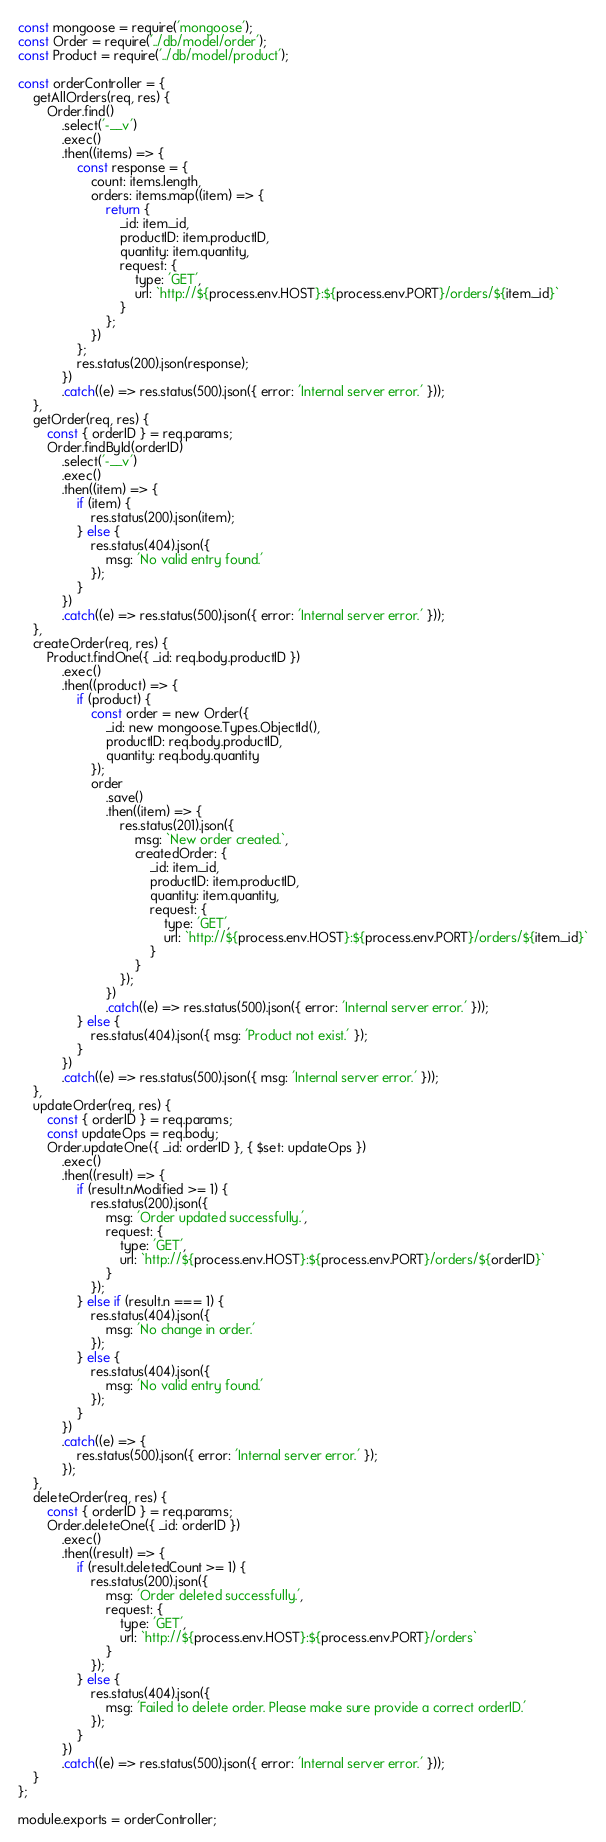<code> <loc_0><loc_0><loc_500><loc_500><_JavaScript_>const mongoose = require('mongoose');
const Order = require('../db/model/order');
const Product = require('../db/model/product');

const orderController = {
    getAllOrders(req, res) {
        Order.find()
            .select('-__v')
            .exec()
            .then((items) => {
                const response = {
                    count: items.length,
                    orders: items.map((item) => {
                        return {
                            _id: item._id,
                            productID: item.productID,
                            quantity: item.quantity,
                            request: {
                                type: 'GET',
                                url: `http://${process.env.HOST}:${process.env.PORT}/orders/${item._id}`
                            }
                        };
                    })
                };
                res.status(200).json(response);
            })
            .catch((e) => res.status(500).json({ error: 'Internal server error.' }));
    },
    getOrder(req, res) {
        const { orderID } = req.params;
        Order.findById(orderID)
            .select('-__v')
            .exec()
            .then((item) => {
                if (item) {
                    res.status(200).json(item);
                } else {
                    res.status(404).json({
                        msg: 'No valid entry found.'
                    });
                }
            })
            .catch((e) => res.status(500).json({ error: 'Internal server error.' }));
    },
    createOrder(req, res) {
        Product.findOne({ _id: req.body.productID })
            .exec()
            .then((product) => {
                if (product) {
                    const order = new Order({
                        _id: new mongoose.Types.ObjectId(),
                        productID: req.body.productID,
                        quantity: req.body.quantity
                    });
                    order
                        .save()
                        .then((item) => {
                            res.status(201).json({
                                msg: `New order created.`,
                                createdOrder: {
                                    _id: item._id,
                                    productID: item.productID,
                                    quantity: item.quantity,
                                    request: {
                                        type: 'GET',
                                        url: `http://${process.env.HOST}:${process.env.PORT}/orders/${item._id}`
                                    }
                                }
                            });
                        })
                        .catch((e) => res.status(500).json({ error: 'Internal server error.' }));
                } else {
                    res.status(404).json({ msg: 'Product not exist.' });
                }
            })
            .catch((e) => res.status(500).json({ msg: 'Internal server error.' }));
    },
    updateOrder(req, res) {
        const { orderID } = req.params;
        const updateOps = req.body;
        Order.updateOne({ _id: orderID }, { $set: updateOps })
            .exec()
            .then((result) => {
                if (result.nModified >= 1) {
                    res.status(200).json({
                        msg: 'Order updated successfully.',
                        request: {
                            type: 'GET',
                            url: `http://${process.env.HOST}:${process.env.PORT}/orders/${orderID}`
                        }
                    });
                } else if (result.n === 1) {
                    res.status(404).json({
                        msg: 'No change in order.'
                    });
                } else {
                    res.status(404).json({
                        msg: 'No valid entry found.'
                    });
                }
            })
            .catch((e) => {
                res.status(500).json({ error: 'Internal server error.' });
            });
    },
    deleteOrder(req, res) {
        const { orderID } = req.params;
        Order.deleteOne({ _id: orderID })
            .exec()
            .then((result) => {
                if (result.deletedCount >= 1) {
                    res.status(200).json({
                        msg: 'Order deleted successfully.',
                        request: {
                            type: 'GET',
                            url: `http://${process.env.HOST}:${process.env.PORT}/orders`
                        }
                    });
                } else {
                    res.status(404).json({
                        msg: 'Failed to delete order. Please make sure provide a correct orderID.'
                    });
                }
            })
            .catch((e) => res.status(500).json({ error: 'Internal server error.' }));
    }
};

module.exports = orderController;
</code> 